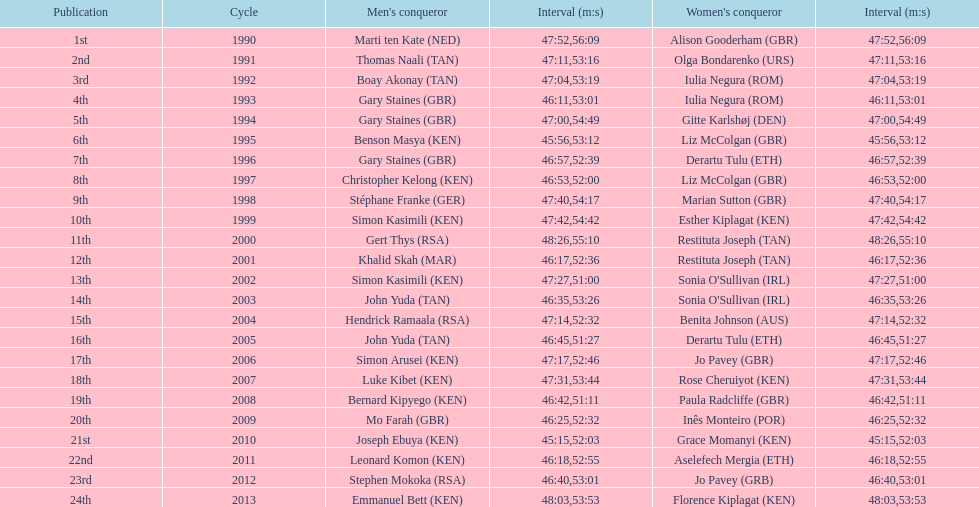How many men winners had times at least 46 minutes or under? 2. 